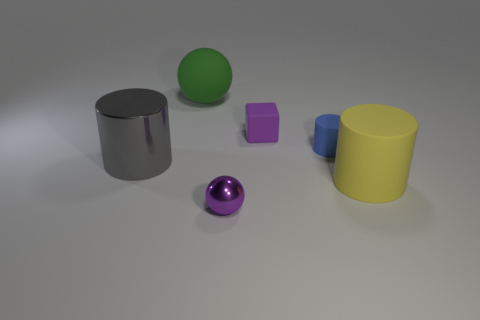Subtract all cubes. How many objects are left? 5 Add 3 gray metallic objects. How many objects exist? 9 Add 4 big balls. How many big balls are left? 5 Add 1 tiny shiny balls. How many tiny shiny balls exist? 2 Subtract 0 brown cylinders. How many objects are left? 6 Subtract all tiny red rubber blocks. Subtract all tiny purple objects. How many objects are left? 4 